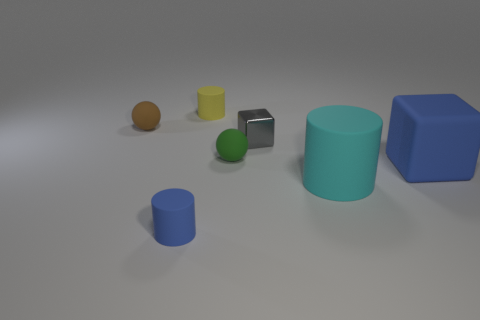Are there any objects of the same color as the large cube?
Provide a short and direct response. Yes. Is the blue rubber cube the same size as the metal thing?
Keep it short and to the point. No. How many things are either tiny gray metal objects on the right side of the tiny brown thing or tiny rubber cylinders?
Your answer should be compact. 3. There is a blue object right of the cube behind the green matte object; what is its shape?
Your answer should be very brief. Cube. There is a yellow rubber cylinder; is its size the same as the blue rubber object left of the tiny gray shiny cube?
Keep it short and to the point. Yes. There is a blue object that is to the right of the small yellow matte thing; what material is it?
Your answer should be very brief. Rubber. How many tiny rubber things are both on the right side of the small brown matte thing and behind the tiny gray block?
Ensure brevity in your answer.  1. There is a gray object that is the same size as the yellow matte thing; what material is it?
Make the answer very short. Metal. There is a cylinder that is on the right side of the small green matte thing; does it have the same size as the sphere that is behind the small green object?
Make the answer very short. No. Are there any brown balls in front of the small blue matte cylinder?
Offer a terse response. No. 